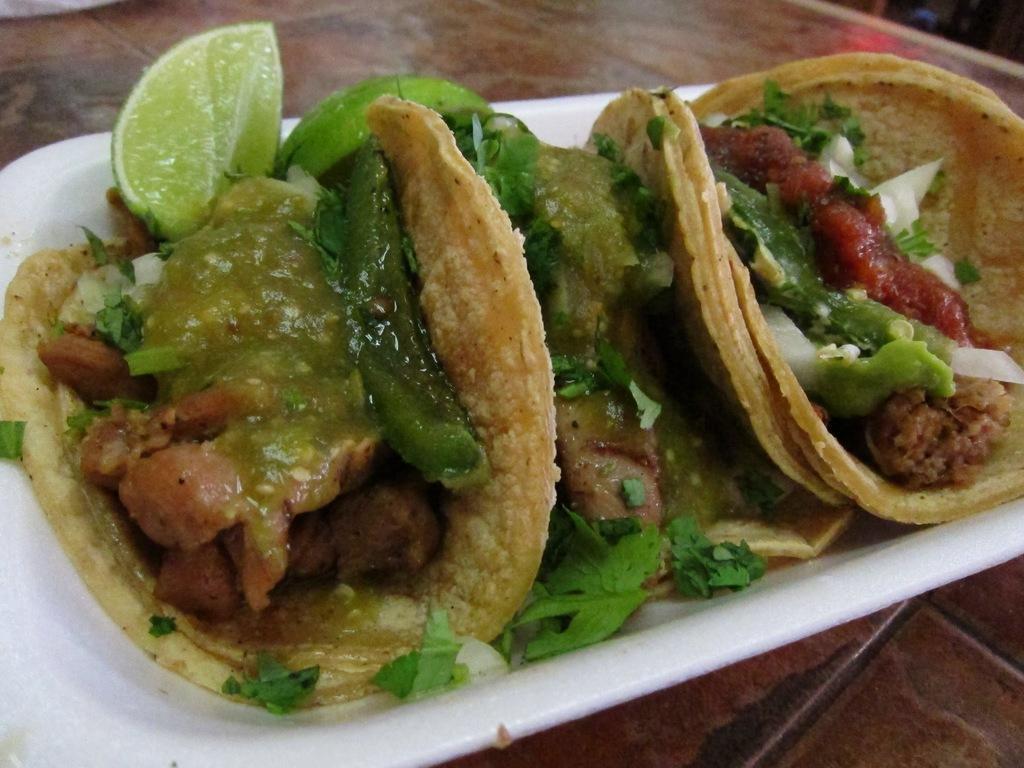Can you describe this image briefly? This picture shows tacos and we see meat and some veggies and lemon pieces in the plate on the table. 